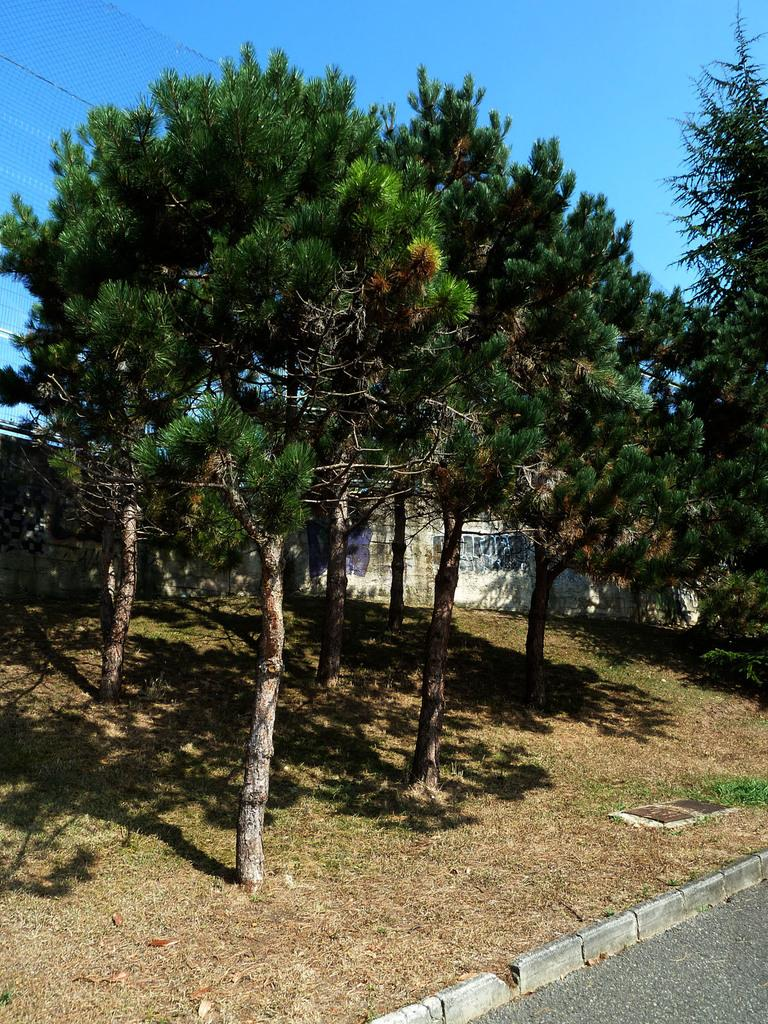What type of vegetation can be seen in the image? There are trees and grass in the image. What structure is present in the image? There is a wall in the image. What object is related to sports or games in the image? There is a net in the image. What part of the natural environment is visible in the image? The sky is visible in the background of the image. Can you see a baby playing with a squirrel on the wall in the image? There is no baby or squirrel present on the wall in the image. Is there a cobweb visible on the net in the image? There is no mention of a cobweb in the image, so we cannot determine its presence. 